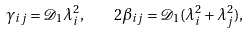<formula> <loc_0><loc_0><loc_500><loc_500>\gamma _ { i j } = \mathcal { D } _ { 1 } \lambda _ { i } ^ { 2 } , \quad 2 \beta _ { i j } = \mathcal { D } _ { 1 } ( \lambda _ { i } ^ { 2 } + \lambda _ { j } ^ { 2 } ) ,</formula> 